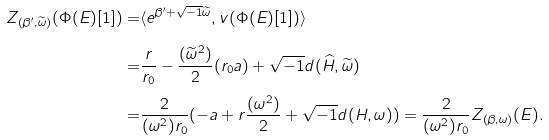Convert formula to latex. <formula><loc_0><loc_0><loc_500><loc_500>Z _ { ( \beta ^ { \prime } , \widetilde { \omega } ) } ( \Phi ( E ) [ 1 ] ) = & \langle e ^ { \beta ^ { \prime } + \sqrt { - 1 } \widetilde { \omega } } , v ( \Phi ( E ) [ 1 ] ) \rangle \\ = & \frac { r } { r _ { 0 } } - \frac { ( \widetilde { \omega } ^ { 2 } ) } { 2 } ( r _ { 0 } a ) + \sqrt { - 1 } d ( \widehat { H } , \widetilde { \omega } ) \\ = & \frac { 2 } { ( \omega ^ { 2 } ) r _ { 0 } } ( - a + r \frac { ( \omega ^ { 2 } ) } { 2 } + \sqrt { - 1 } d ( H , \omega ) ) = \frac { 2 } { ( \omega ^ { 2 } ) r _ { 0 } } Z _ { ( \beta , \omega ) } ( E ) .</formula> 